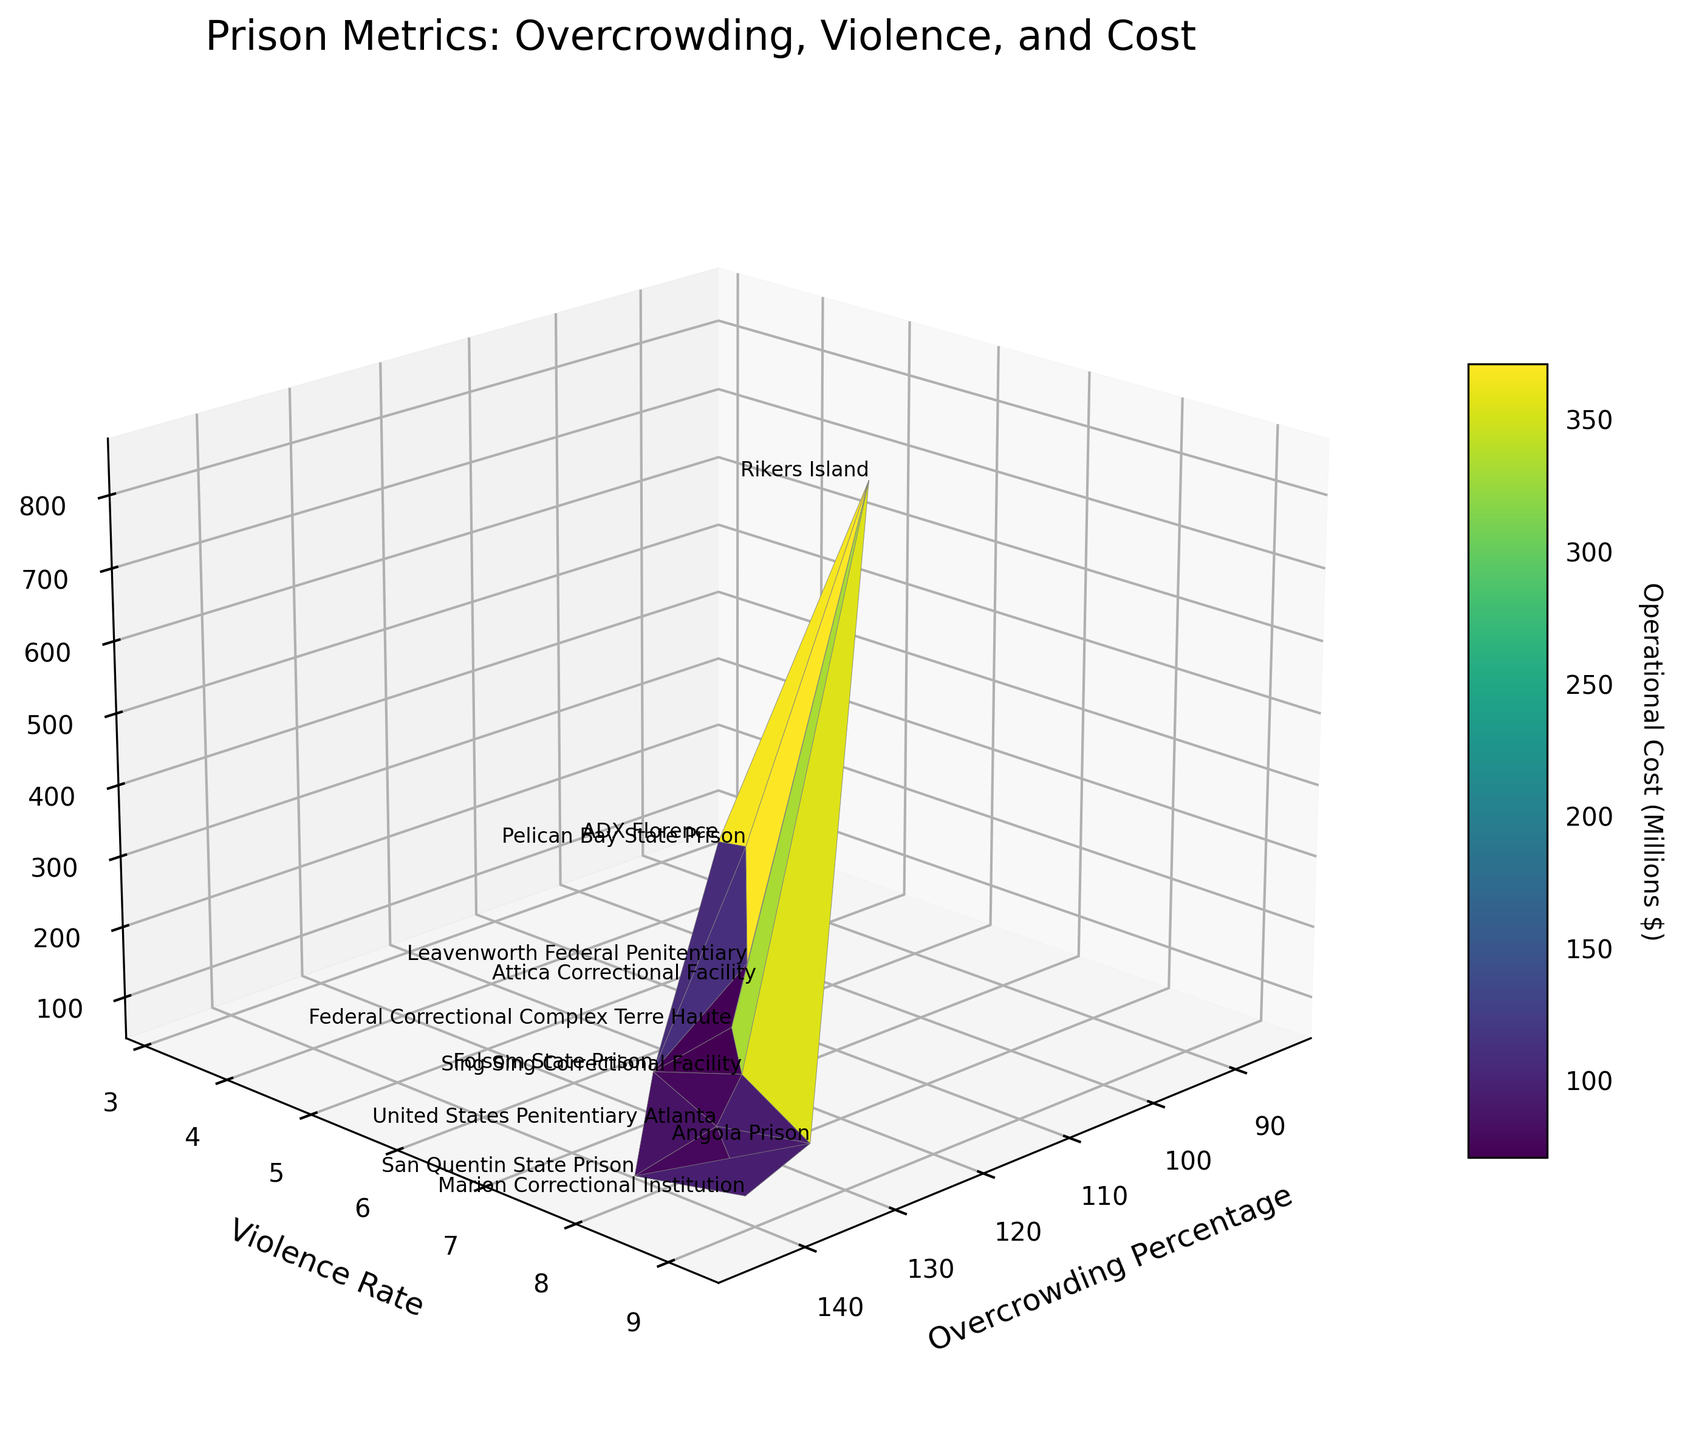What is the title of the figure? The title is displayed at the top of the figure in a larger font size.
Answer: Prison Metrics: Overcrowding, Violence, and Cost Which axis represents the violence rate? The label on the y-axis indicates it represents the violence rate.
Answer: The y-axis How many data points are represented in the plot? Count the number of facility names annotated in the plot.
Answer: 12 Which facility has the highest level of overcrowding? Examine the facilities' names on the 3D surface plot and identify the one corresponding to the highest value on the x-axis (Overcrowding Percentage).
Answer: San Quentin State Prison What is the operational cost of the facility with the lowest violence rate? Locate the lowest value on the y-axis (Violence Rate), find the corresponding facility name, then trace to find its value on the z-axis (Operational Cost).
Answer: ADX Florence Which facility has the highest operational cost? Identify the facility name next to the highest value on the z-axis (Operational Cost).
Answer: Rikers Island Are there any facilities with violence rates below 5? If so, name them. Look for data points on the y-axis (Violence Rate) with values below 5 and identify the corresponding facility names.
Answer: Pelican Bay State Prison, ADX Florence How does the overcrowding percentage relate to operational costs based on the surface plot? Observe the trend on the 3D plot between the x-axis (Overcrowding Percentage) and the z-axis (Operational Cost). The patterns and colors on the plot indicate the relationship.
Answer: Generally, higher overcrowding percentages correlate with higher operational costs Which facilities have both high violence rates and high operational costs? Determine the high values on both the y-axis (Violence Rate) and z-axis (Operational Cost) simultaneously and identify those facilities.
Answer: Angola Prison, United States Penitentiary Atlanta, Rikers Island What is the range of operational costs in millions of dollars depicted in this plot? Assess the values on the z-axis (Operational Cost) from the lowest to the highest annotated data points and convert to millions if necessary.
Answer: Approximately $58 million to $860 million 